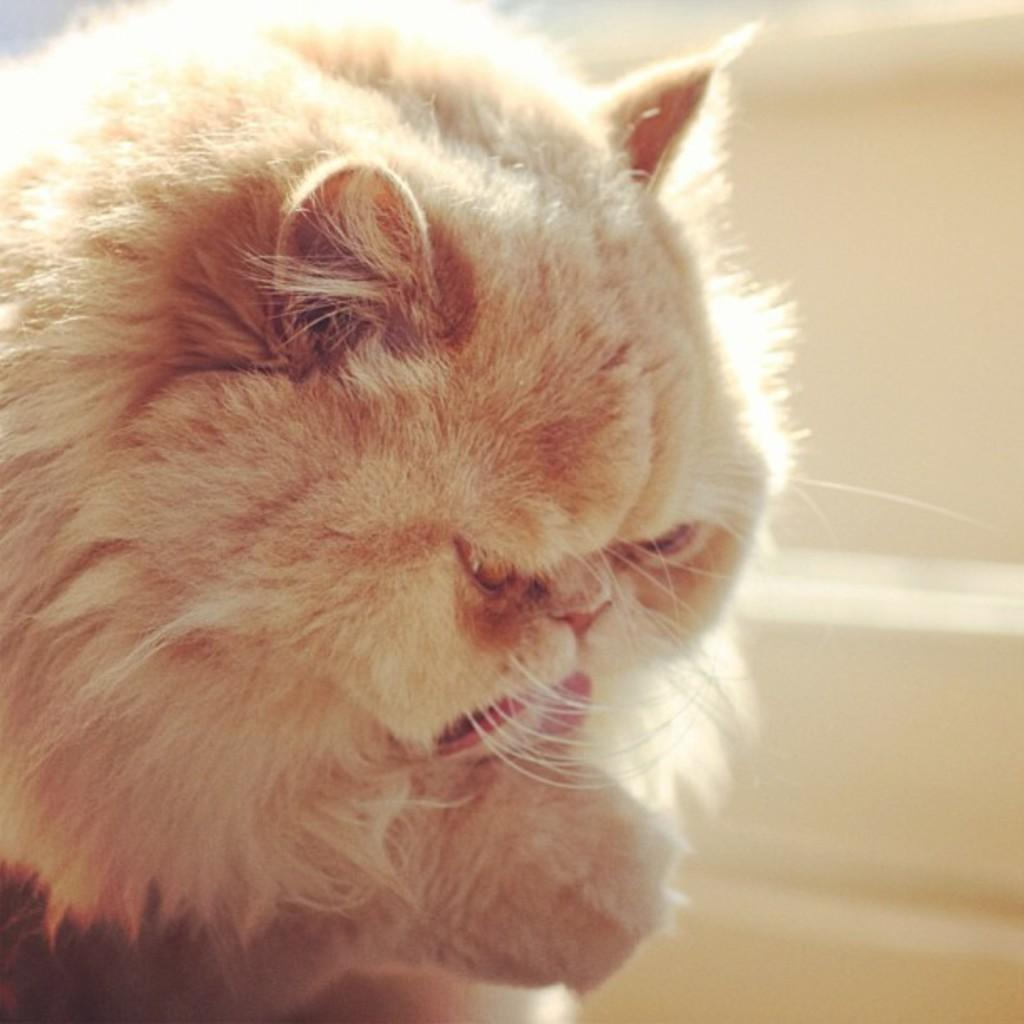What type of animal is in the image? There is a cat in the image. What is behind the cat in the image? There is a wall behind the cat in the image. Where is the toothbrush located in the image? There is no toothbrush present in the image. What type of animal is standing next to the zebra in the image? There is no zebra present in the image, so it is not possible to determine what type of animal might be standing next to it. 